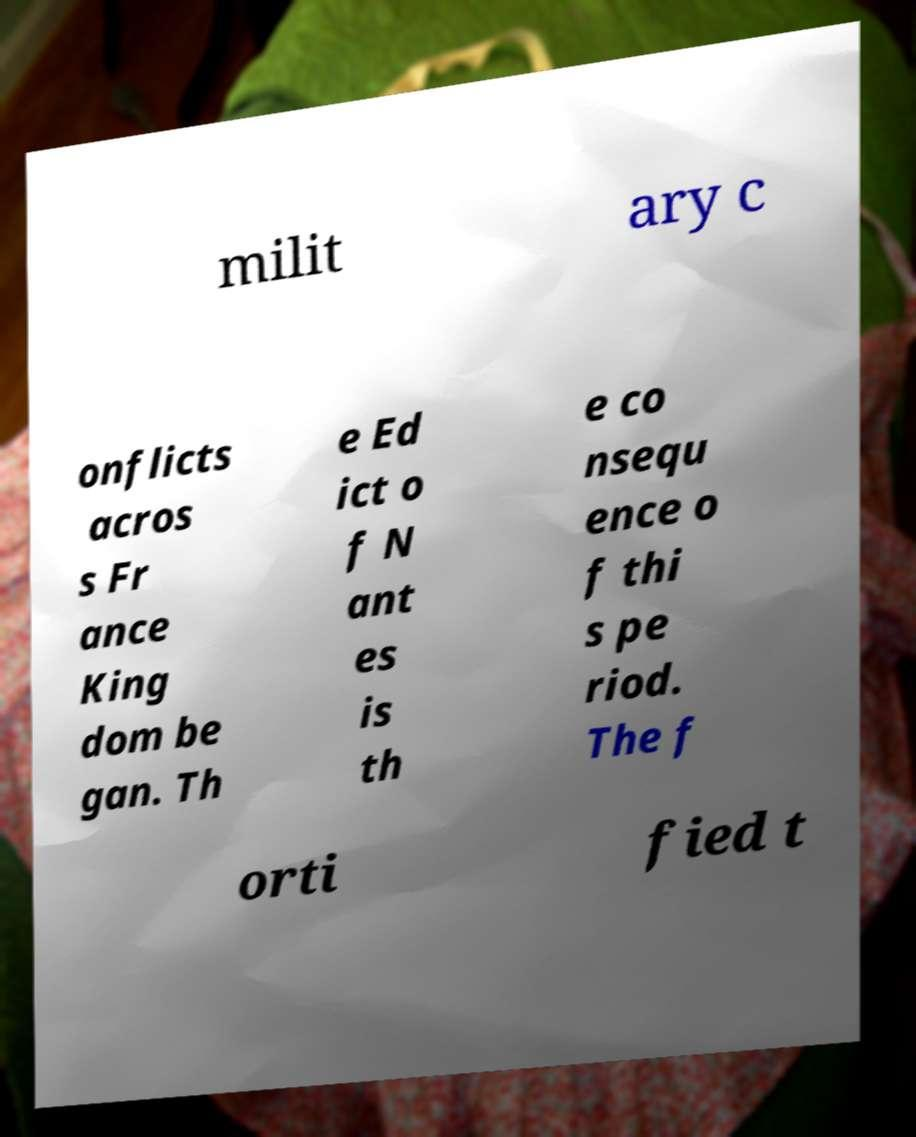There's text embedded in this image that I need extracted. Can you transcribe it verbatim? milit ary c onflicts acros s Fr ance King dom be gan. Th e Ed ict o f N ant es is th e co nsequ ence o f thi s pe riod. The f orti fied t 